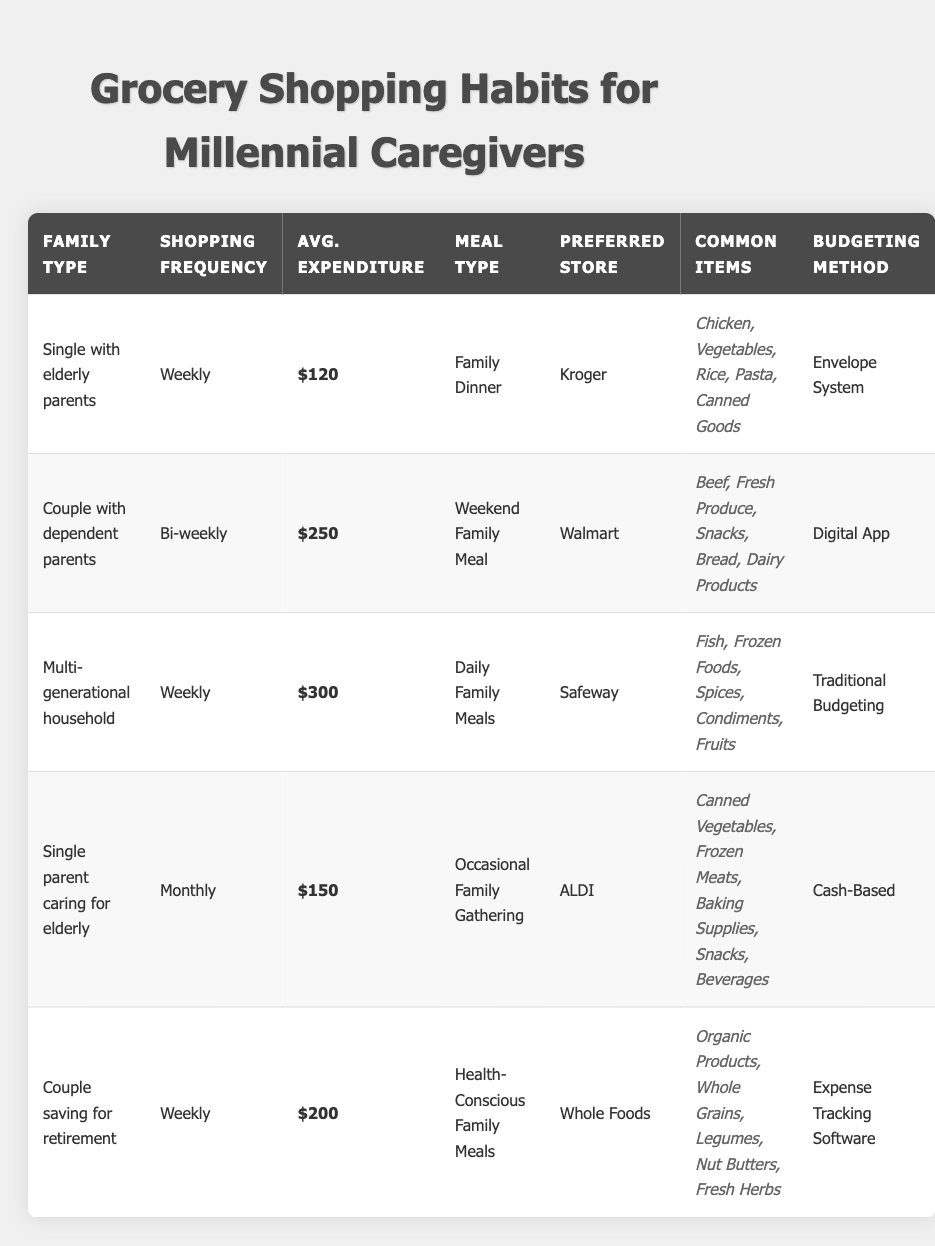What is the shopping frequency for a single parent caring for the elderly? The table lists the shopping frequency for a single parent caring for elderly as "Monthly."
Answer: Monthly Which family type has the highest average expenditure per trip? The table shows that the multi-generational household has the highest average expenditure at $300 per trip.
Answer: Multi-generational household What is the total average expenditure for all family types listed? To find the total average expenditure, sum the averages: 120 + 250 + 300 + 150 + 200 = 1020.
Answer: 1020 Is the preferred store for a couple saving for retirement Whole Foods? The table confirms that the preferred store for the couple saving for retirement is indeed Whole Foods.
Answer: Yes What is the difference in average expenditure between the multi-generational household and the couple with dependent parents? Multi-generational household average expenditure is $300 and couple with dependent parents is $250. The difference is 300 - 250 = 50.
Answer: 50 How many family types shop weekly, and what are they? The table has two family types that shop weekly: "Single with elderly parents" and "Multi-generational household." Thus, there are 2 family types.
Answer: 2 Which budgeting method is most commonly used by the family types with the highest expenditure? The multi-generational household and couple with dependent parents both use different budgeting methods: traditional budgeting and digital app respectively. There is no single method prevalent among the highest spenders.
Answer: No common method What meal type is associated with the couple with dependent parents? Referring to the table, the meal type associated with the couple with dependent parents is "Weekend Family Meal."
Answer: Weekend Family Meal Which common items does the “Single with elderly parents” family type purchase? The common items listed for the single with elderly parents include Chicken, Vegetables, Rice, Pasta, and Canned Goods.
Answer: Chicken, Vegetables, Rice, Pasta, Canned Goods What is the average expenditure of the family types that shop weekly? The average expenditure for the two types that shop weekly is calculated as follows: (120 + 300 + 200) / 3 = 206.67, approximately.
Answer: Approximately 206.67 